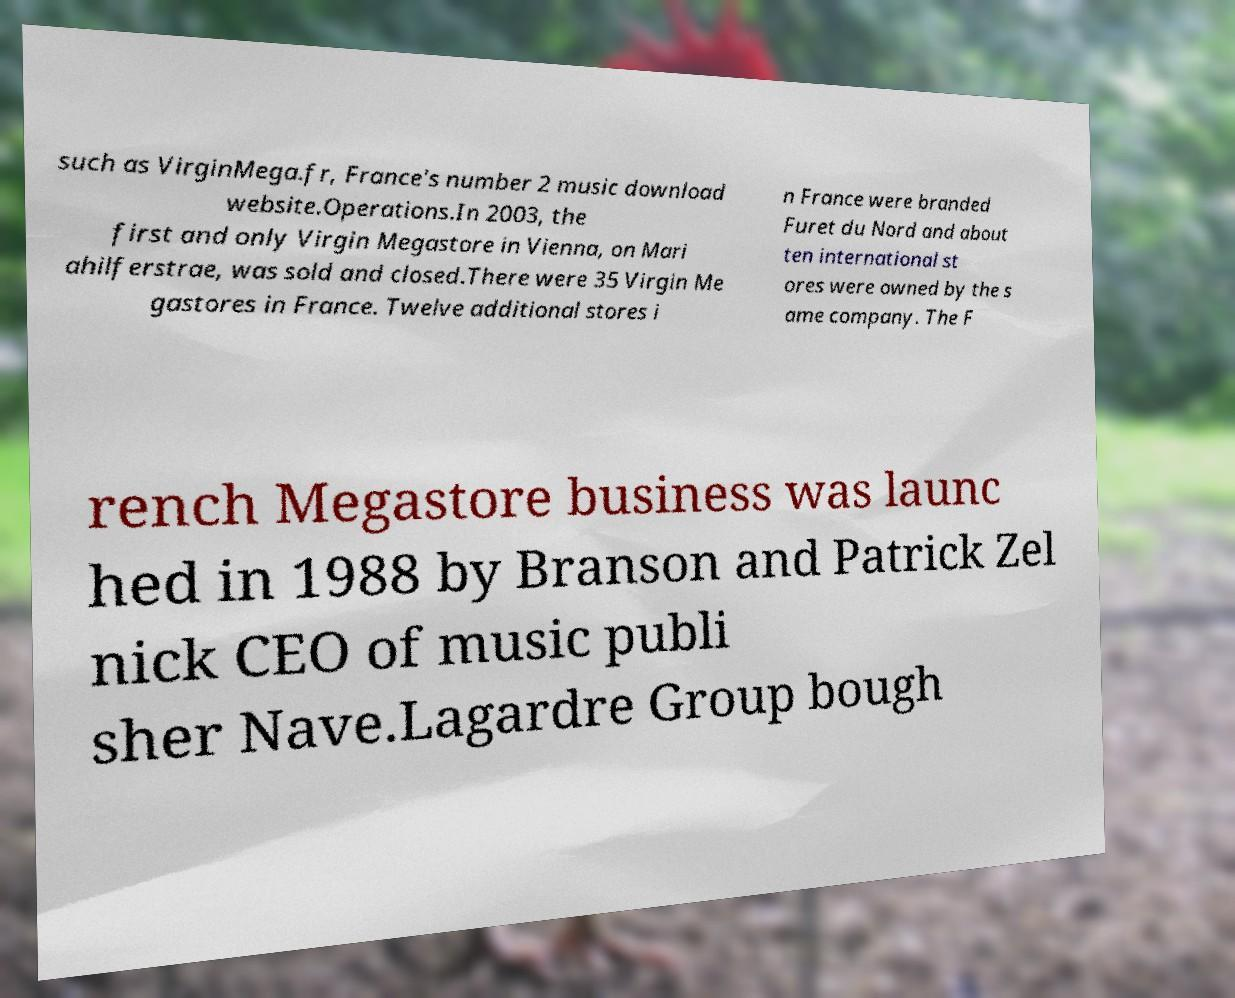There's text embedded in this image that I need extracted. Can you transcribe it verbatim? such as VirginMega.fr, France's number 2 music download website.Operations.In 2003, the first and only Virgin Megastore in Vienna, on Mari ahilferstrae, was sold and closed.There were 35 Virgin Me gastores in France. Twelve additional stores i n France were branded Furet du Nord and about ten international st ores were owned by the s ame company. The F rench Megastore business was launc hed in 1988 by Branson and Patrick Zel nick CEO of music publi sher Nave.Lagardre Group bough 